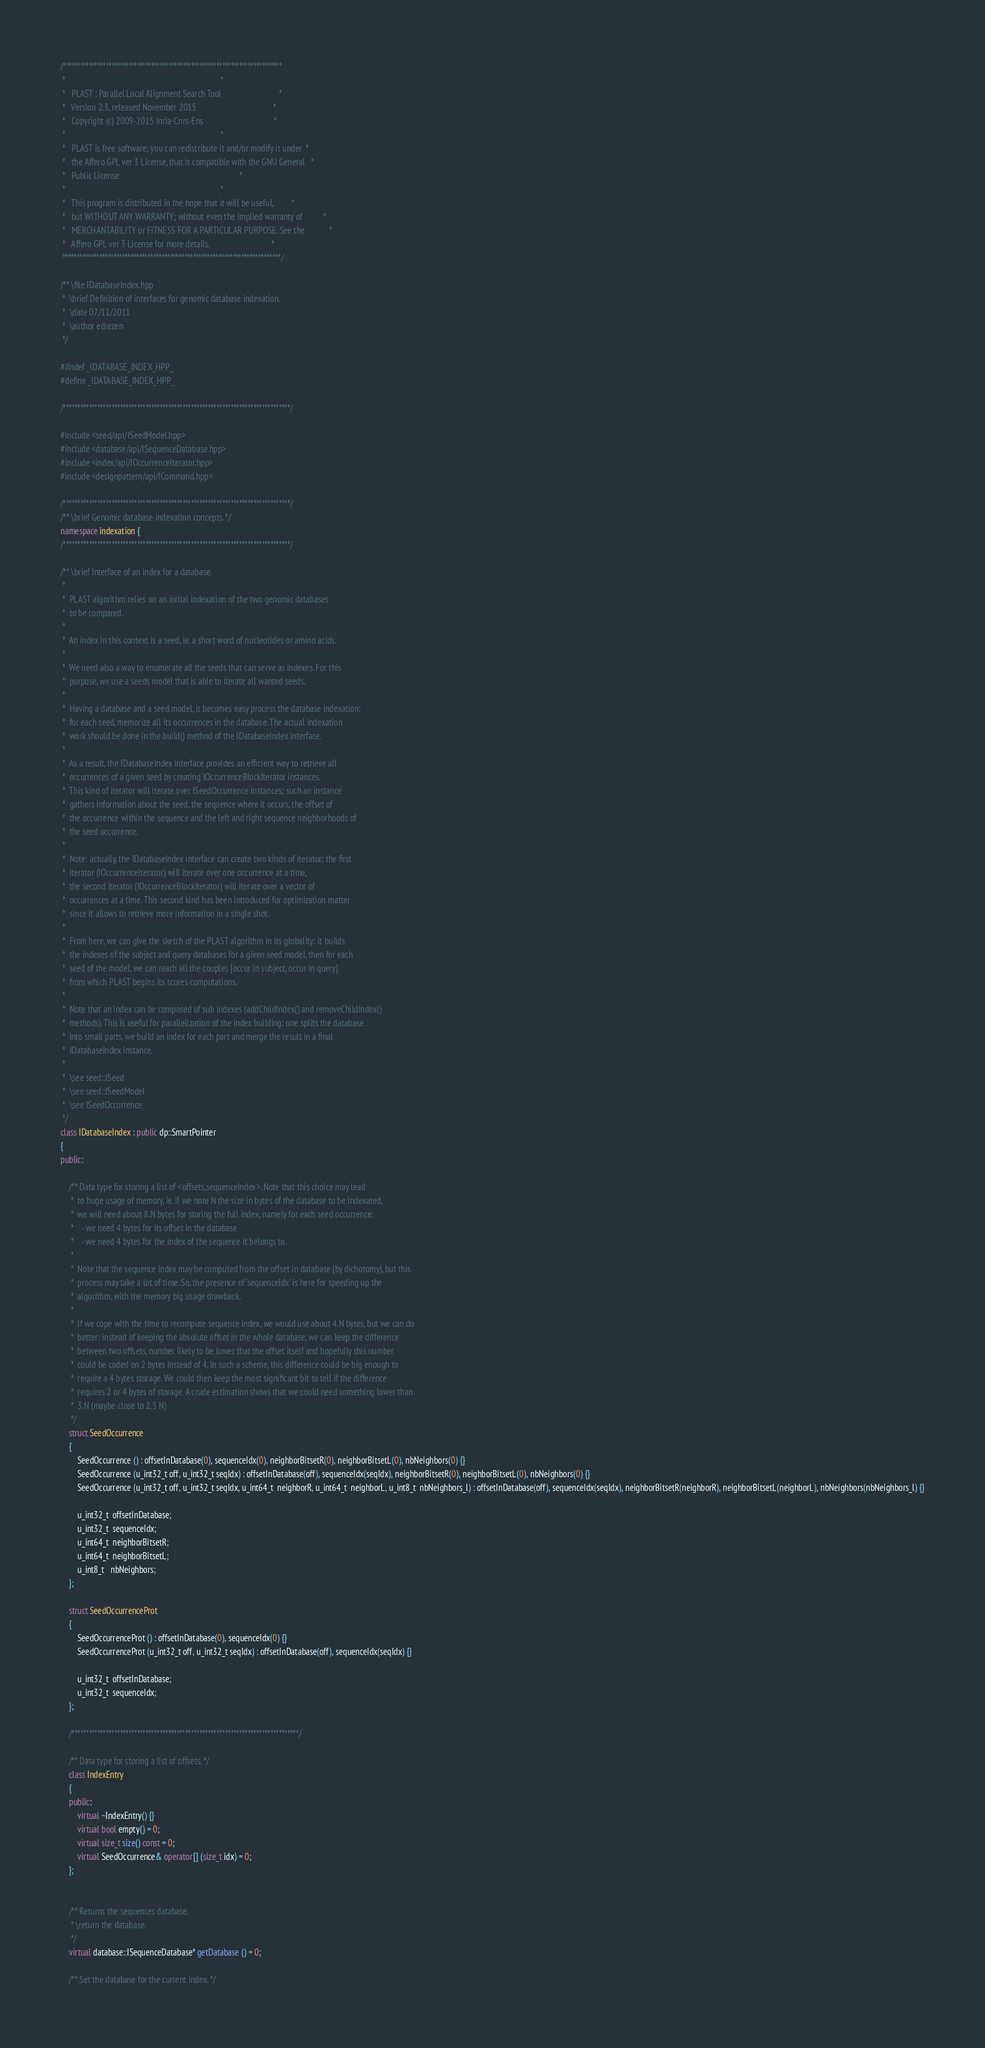<code> <loc_0><loc_0><loc_500><loc_500><_C++_>/*****************************************************************************
 *                                                                           *
 *   PLAST : Parallel Local Alignment Search Tool                            *
 *   Version 2.3, released November 2015                                     *
 *   Copyright (c) 2009-2015 Inria-Cnrs-Ens                                  *
 *                                                                           *
 *   PLAST is free software; you can redistribute it and/or modify it under  *
 *   the Affero GPL ver 3 License, that is compatible with the GNU General   *
 *   Public License                                                          *
 *                                                                           *
 *   This program is distributed in the hope that it will be useful,         *
 *   but WITHOUT ANY WARRANTY; without even the implied warranty of          *
 *   MERCHANTABILITY or FITNESS FOR A PARTICULAR PURPOSE. See the            *
 *   Affero GPL ver 3 License for more details.                              *
 *****************************************************************************/

/** \file IDatabaseIndex.hpp
 *  \brief Definition of interfaces for genomic database indexation.
 *  \date 07/11/2011
 *  \author edrezen
 */

#ifndef _IDATABASE_INDEX_HPP_
#define _IDATABASE_INDEX_HPP_

/********************************************************************************/

#include <seed/api/ISeedModel.hpp>
#include <database/api/ISequenceDatabase.hpp>
#include <index/api/IOccurrenceIterator.hpp>
#include <designpattern/api/ICommand.hpp>

/********************************************************************************/
/** \brief Genomic database indexation concepts. */
namespace indexation {
/********************************************************************************/

/** \brief Interface of an index for a database.
 *
 *  PLAST algorithm relies on an initial indexation of the two genomic databases
 *  to be compared.
 *
 *  An index in this context is a seed, ie. a short word of nucleotides or amino acids.
 *
 *  We need also a way to enumerate all the seeds that can serve as indexes. For this
 *  purpose, we use a seeds model that is able to iterate all wanted seeds.
 *
 *  Having a database and a seed model, it becomes easy process the database indexation:
 *  for each seed, memorize all its occurrences in the database. The actual indexation
 *  work should be done in the build() method of the IDatabaseIndex interface.
 *
 *  As a result, the IDatabaseIndex interface provides an efficient way to retrieve all
 *  occurrences of a given seed by creating IOccurrenceBlockIterator instances.
 *  This kind of iterator will iterate over ISeedOccurrence instances; such an instance
 *  gathers information about the seed, the sequence where it occurs, the offset of
 *  the occurrence within the sequence and the left and right sequence neighborhoods of
 *  the seed occurrence.
 *
 *  Note: actually, the IDatabaseIndex interface can create two kinds of iterator: the first
 *  iterator (IOccurrenceIterator) will iterate over one occurrence at a time,
 *  the second iterator (IOccurrenceBlockIterator) will iterate over a vector of
 *  occurrences at a time. This second kind has been introduced for optimization matter
 *  since it allows to retrieve more information in a single shot.
 *
 *  From here, we can give the sketch of the PLAST algorithm in its globality: it builds
 *  the indexes of the subject and query databases for a given seed model, then for each
 *  seed of the model, we can reach all the couples [occur in subject, occur in query]
 *  from which PLAST begins its scores computations.
 *
 *  Note that an index can be composed of sub indexes (addChildIndex() and removeChildIndex()
 *  methods). This is useful for parallelization of the index building: one splits the database
 *  into small parts, we build an index for each part and merge the result in a final
 *  IDatabaseIndex instance.
 *
 *  \see seed::ISeed
 *  \see seed::ISeedModel
 *  \see ISeedOccurrence
 */
class IDatabaseIndex : public dp::SmartPointer
{
public:

    /** Data type for storing a list of <offsets,sequenceIndex>. Note that this choice may lead
     *  to huge usage of memory, ie. if we note N the size in bytes of the database to be indexated,
     *  we will need about 8.N bytes for storing the full index, namely for each seed occurrence:
     *    - we need 4 bytes for its offset in the database
     *    - we need 4 bytes for the index of the sequence it belongs to.
     *
     *  Note that the sequence index may be computed from the offset in database (by dichotomy), but this
     *  process may take a lot of time. So, the presence of 'sequenceIdx' is here for speeding up the
     *  algorithm, with the memory big usage drawback.
     *
     *  If we cope with the time to recompute sequence index, we would use about 4.N bytes, but we can do
     *  better: instead of keeping the absolute offset in the whole database, we can keep the difference
     *  between two offsets, number likely to be lower that the offset itself and hopefully this number
     *  could be coded on 2 bytes instead of 4. In such a scheme, this difference could be big enough to
     *  require a 4 bytes storage. We could then keep the most significant bit to tell if the difference
     *  requires 2 or 4 bytes of storage. A crude estimation shows that we could need something lower than
     *  3.N (maybe close to 2.5 N)
     */
    struct SeedOccurrence
    {
        SeedOccurrence () : offsetInDatabase(0), sequenceIdx(0), neighborBitsetR(0), neighborBitsetL(0), nbNeighbors(0) {}
        SeedOccurrence (u_int32_t off, u_int32_t seqIdx) : offsetInDatabase(off), sequenceIdx(seqIdx), neighborBitsetR(0), neighborBitsetL(0), nbNeighbors(0) {}
        SeedOccurrence (u_int32_t off, u_int32_t seqIdx, u_int64_t  neighborR, u_int64_t  neighborL, u_int8_t  nbNeighbors_l) : offsetInDatabase(off), sequenceIdx(seqIdx), neighborBitsetR(neighborR), neighborBitsetL(neighborL), nbNeighbors(nbNeighbors_l) {}

        u_int32_t  offsetInDatabase;
        u_int32_t  sequenceIdx;
        u_int64_t  neighborBitsetR;
        u_int64_t  neighborBitsetL;
        u_int8_t   nbNeighbors;
    };

    struct SeedOccurrenceProt
    {
        SeedOccurrenceProt () : offsetInDatabase(0), sequenceIdx(0) {}
        SeedOccurrenceProt (u_int32_t off, u_int32_t seqIdx) : offsetInDatabase(off), sequenceIdx(seqIdx) {}

        u_int32_t  offsetInDatabase;
        u_int32_t  sequenceIdx;
    };

    /********************************************************************************/

    /** Data type for storing a list of offsets. */
    class IndexEntry
    {
    public:
        virtual ~IndexEntry() {}
        virtual bool empty() = 0;
        virtual size_t size() const = 0;
        virtual SeedOccurrence& operator[] (size_t idx) = 0;
    };


    /** Returns the sequences database.
     * \return the database.
     */
    virtual database::ISequenceDatabase* getDatabase () = 0;

 	/** Set the database for the current index. */</code> 